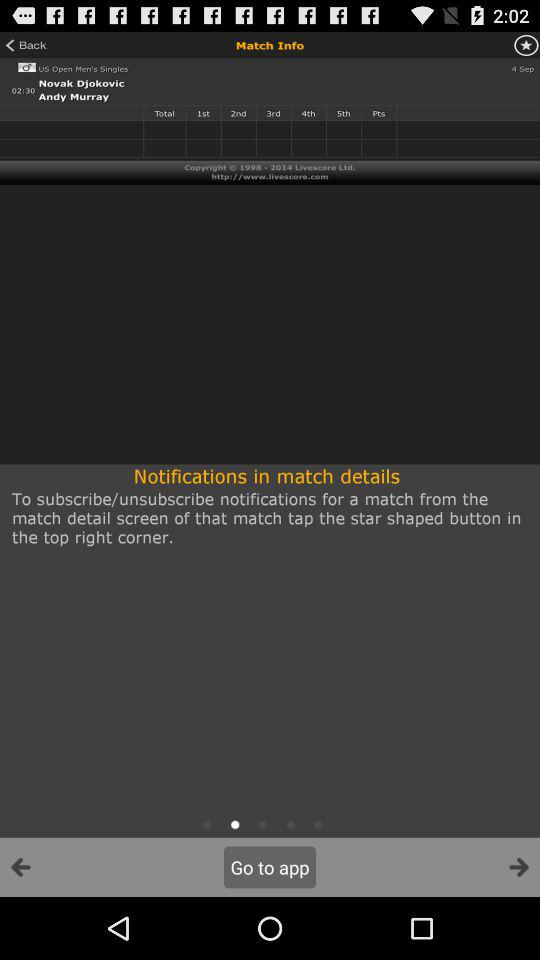When is the match scheduled to take place? The match is scheduled to take place on September 4 at 2:30. 